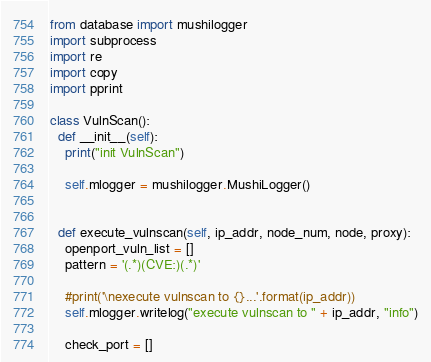Convert code to text. <code><loc_0><loc_0><loc_500><loc_500><_Python_>from database import mushilogger
import subprocess
import re
import copy
import pprint

class VulnScan():
  def __init__(self):
    print("init VulnScan")

    self.mlogger = mushilogger.MushiLogger()


  def execute_vulnscan(self, ip_addr, node_num, node, proxy):
    openport_vuln_list = []
    pattern = '(.*)(CVE:)(.*)'
  
    #print('\nexecute vulnscan to {}...'.format(ip_addr))
    self.mlogger.writelog("execute vulnscan to " + ip_addr, "info")

    check_port = []
</code> 